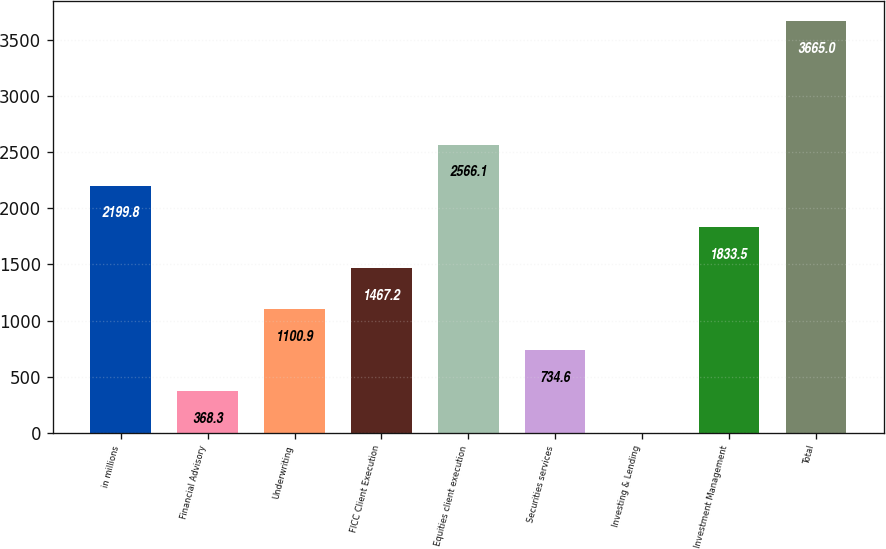Convert chart. <chart><loc_0><loc_0><loc_500><loc_500><bar_chart><fcel>in millions<fcel>Financial Advisory<fcel>Underwriting<fcel>FICC Client Execution<fcel>Equities client execution<fcel>Securities services<fcel>Investing & Lending<fcel>Investment Management<fcel>Total<nl><fcel>2199.8<fcel>368.3<fcel>1100.9<fcel>1467.2<fcel>2566.1<fcel>734.6<fcel>2<fcel>1833.5<fcel>3665<nl></chart> 